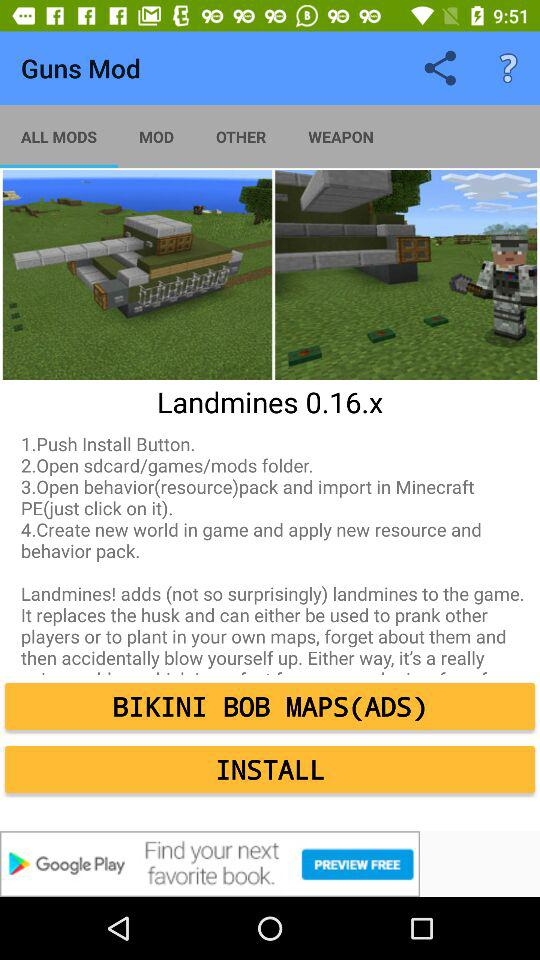What is the name of the mod? The name of the mod is "Landmines 0.16.x". 